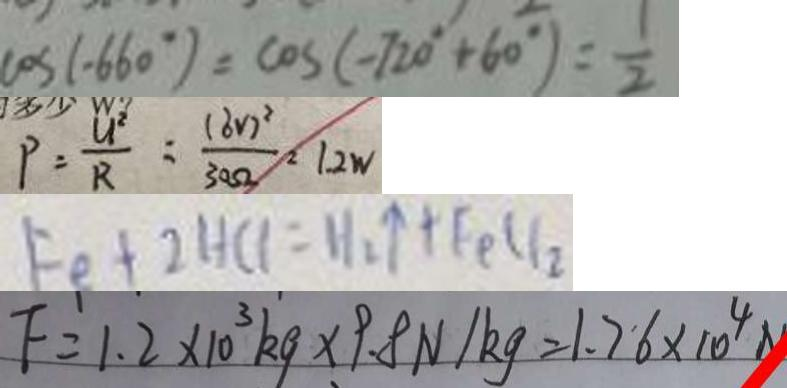<formula> <loc_0><loc_0><loc_500><loc_500>\cos ( - 6 6 0 ^ { \circ } ) = \cos ( - 7 2 0 ^ { \circ } + 6 0 ^ { \circ } ) = \frac { 1 } { 2 } 
 P = \frac { U ^ { 2 } } { R } = \frac { ( 6 V ) } { 3 0 \Omega } ^ { 2 } = 1 2 W 
 F e + 2 H C l = H _ { 2 } \uparrow + F e C l _ { 2 } 
 F = 1 . 2 \times 1 0 ^ { 3 } k g \times 9 . 8 N / k g = 1 . 7 6 \times 1 0 ^ { 4 } N</formula> 